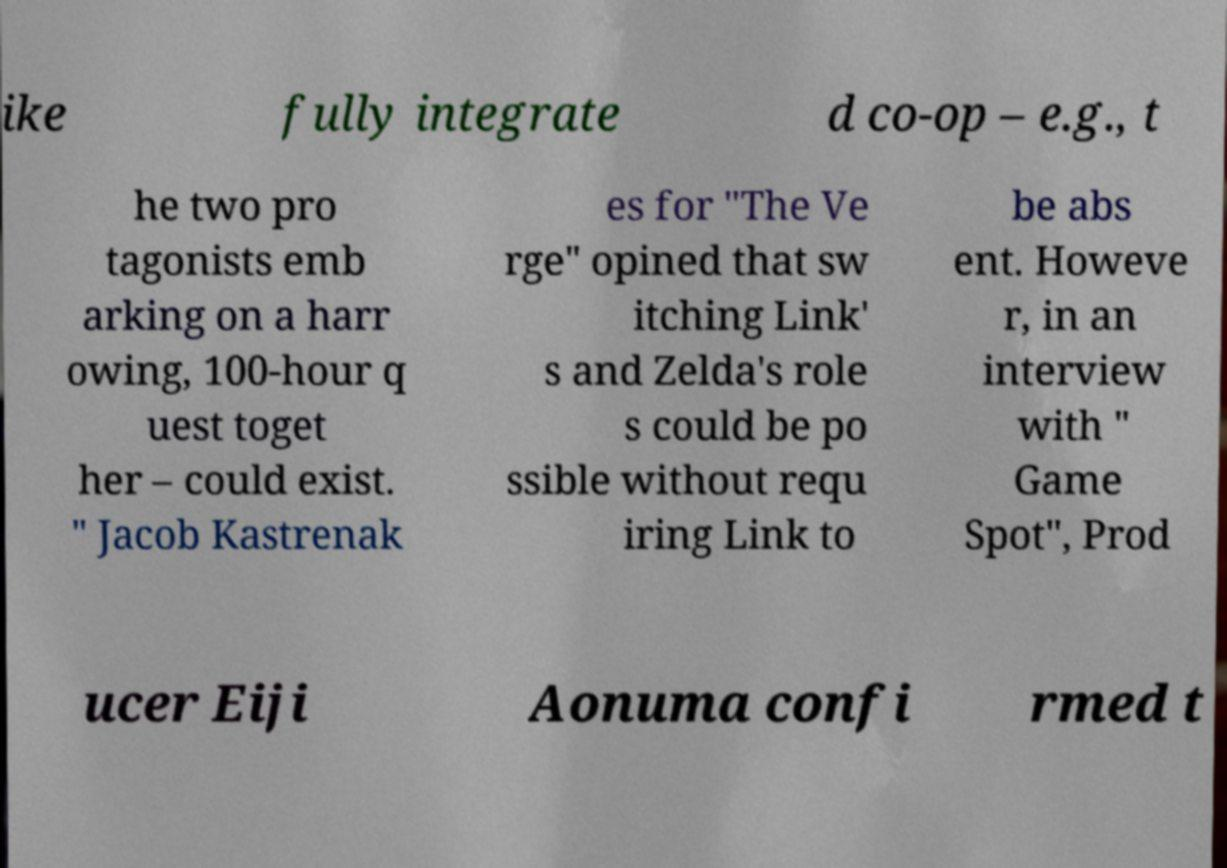I need the written content from this picture converted into text. Can you do that? ike fully integrate d co-op – e.g., t he two pro tagonists emb arking on a harr owing, 100-hour q uest toget her – could exist. " Jacob Kastrenak es for "The Ve rge" opined that sw itching Link' s and Zelda's role s could be po ssible without requ iring Link to be abs ent. Howeve r, in an interview with " Game Spot", Prod ucer Eiji Aonuma confi rmed t 